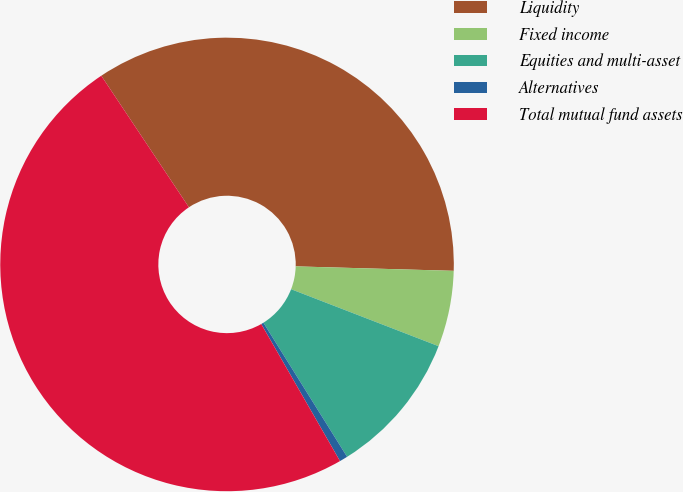Convert chart to OTSL. <chart><loc_0><loc_0><loc_500><loc_500><pie_chart><fcel>Liquidity<fcel>Fixed income<fcel>Equities and multi-asset<fcel>Alternatives<fcel>Total mutual fund assets<nl><fcel>34.8%<fcel>5.42%<fcel>10.25%<fcel>0.58%<fcel>48.94%<nl></chart> 